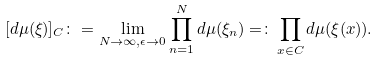<formula> <loc_0><loc_0><loc_500><loc_500>[ d \mu ( \xi ) ] _ { C } \colon = \lim _ { N \rightarrow \infty , \epsilon \rightarrow 0 } \prod _ { n = 1 } ^ { N } d \mu ( \xi _ { n } ) = \colon \prod _ { x \in C } d \mu ( \xi ( x ) ) .</formula> 